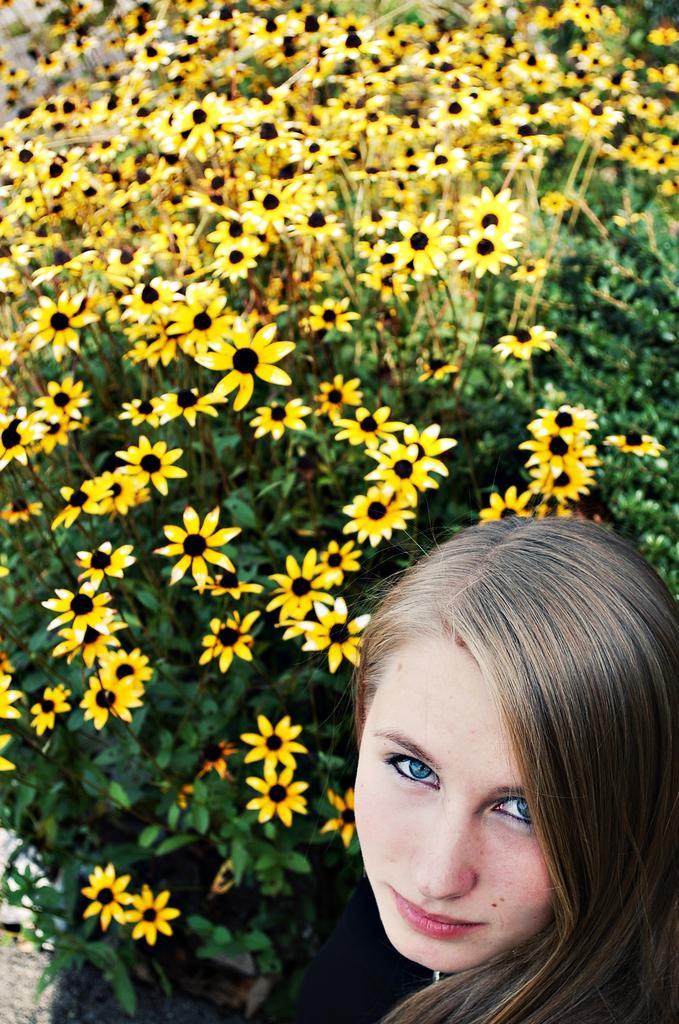How would you summarize this image in a sentence or two? In this image in the foreground there is one woman, and in the background there are some flowers and plants. 